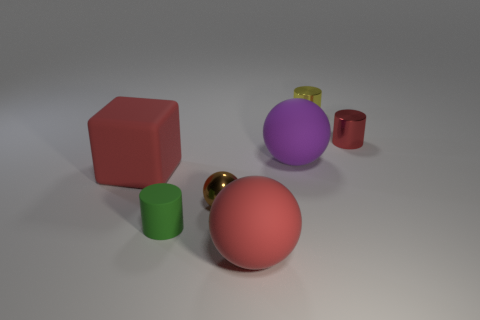Add 2 large green things. How many objects exist? 9 Subtract all cubes. How many objects are left? 6 Add 7 tiny matte things. How many tiny matte things are left? 8 Add 5 blocks. How many blocks exist? 6 Subtract 0 cyan cubes. How many objects are left? 7 Subtract all matte balls. Subtract all matte cylinders. How many objects are left? 4 